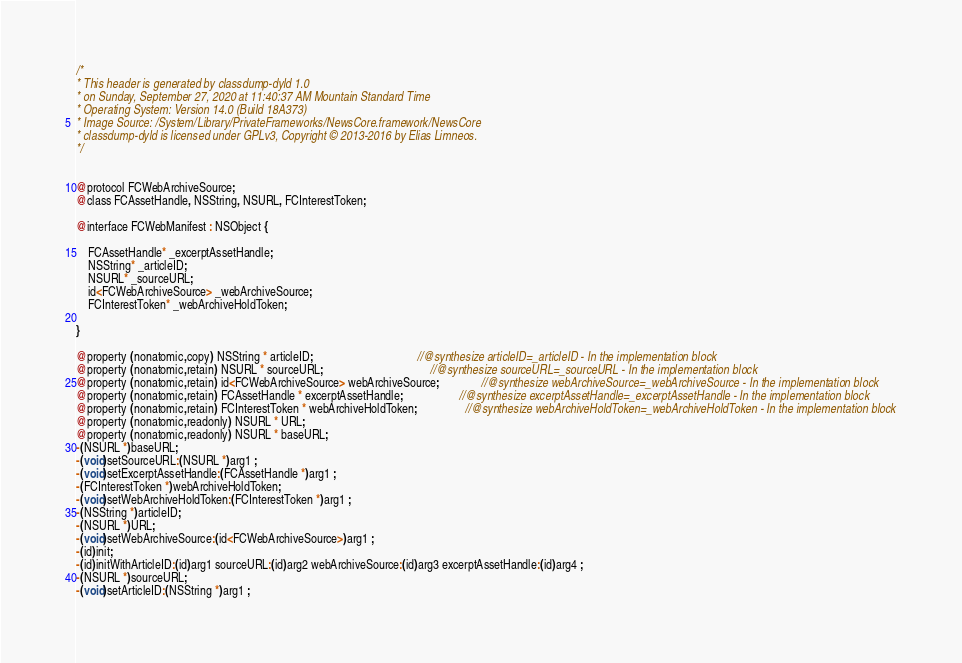<code> <loc_0><loc_0><loc_500><loc_500><_C_>/*
* This header is generated by classdump-dyld 1.0
* on Sunday, September 27, 2020 at 11:40:37 AM Mountain Standard Time
* Operating System: Version 14.0 (Build 18A373)
* Image Source: /System/Library/PrivateFrameworks/NewsCore.framework/NewsCore
* classdump-dyld is licensed under GPLv3, Copyright © 2013-2016 by Elias Limneos.
*/


@protocol FCWebArchiveSource;
@class FCAssetHandle, NSString, NSURL, FCInterestToken;

@interface FCWebManifest : NSObject {

	FCAssetHandle* _excerptAssetHandle;
	NSString* _articleID;
	NSURL* _sourceURL;
	id<FCWebArchiveSource> _webArchiveSource;
	FCInterestToken* _webArchiveHoldToken;

}

@property (nonatomic,copy) NSString * articleID;                                   //@synthesize articleID=_articleID - In the implementation block
@property (nonatomic,retain) NSURL * sourceURL;                                    //@synthesize sourceURL=_sourceURL - In the implementation block
@property (nonatomic,retain) id<FCWebArchiveSource> webArchiveSource;              //@synthesize webArchiveSource=_webArchiveSource - In the implementation block
@property (nonatomic,retain) FCAssetHandle * excerptAssetHandle;                   //@synthesize excerptAssetHandle=_excerptAssetHandle - In the implementation block
@property (nonatomic,retain) FCInterestToken * webArchiveHoldToken;                //@synthesize webArchiveHoldToken=_webArchiveHoldToken - In the implementation block
@property (nonatomic,readonly) NSURL * URL; 
@property (nonatomic,readonly) NSURL * baseURL; 
-(NSURL *)baseURL;
-(void)setSourceURL:(NSURL *)arg1 ;
-(void)setExcerptAssetHandle:(FCAssetHandle *)arg1 ;
-(FCInterestToken *)webArchiveHoldToken;
-(void)setWebArchiveHoldToken:(FCInterestToken *)arg1 ;
-(NSString *)articleID;
-(NSURL *)URL;
-(void)setWebArchiveSource:(id<FCWebArchiveSource>)arg1 ;
-(id)init;
-(id)initWithArticleID:(id)arg1 sourceURL:(id)arg2 webArchiveSource:(id)arg3 excerptAssetHandle:(id)arg4 ;
-(NSURL *)sourceURL;
-(void)setArticleID:(NSString *)arg1 ;</code> 